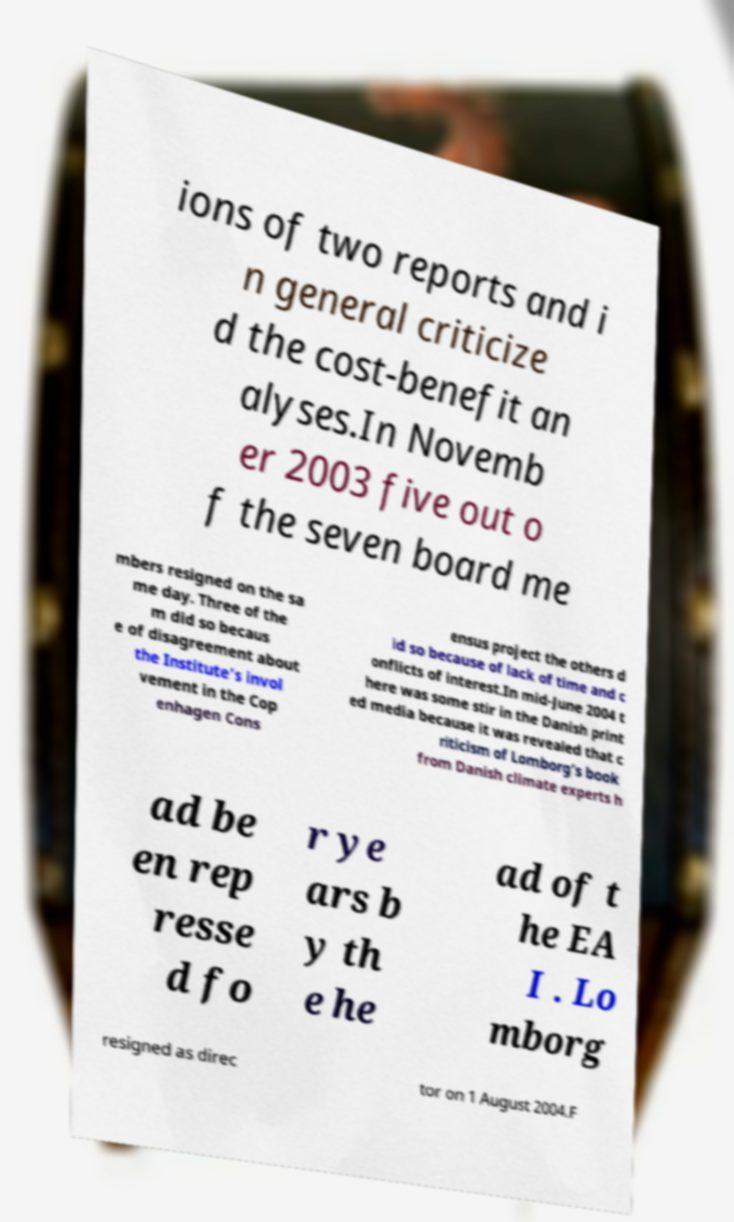What messages or text are displayed in this image? I need them in a readable, typed format. ions of two reports and i n general criticize d the cost-benefit an alyses.In Novemb er 2003 five out o f the seven board me mbers resigned on the sa me day. Three of the m did so becaus e of disagreement about the Institute's invol vement in the Cop enhagen Cons ensus project the others d id so because of lack of time and c onflicts of interest.In mid-June 2004 t here was some stir in the Danish print ed media because it was revealed that c riticism of Lomborg’s book from Danish climate experts h ad be en rep resse d fo r ye ars b y th e he ad of t he EA I . Lo mborg resigned as direc tor on 1 August 2004.F 